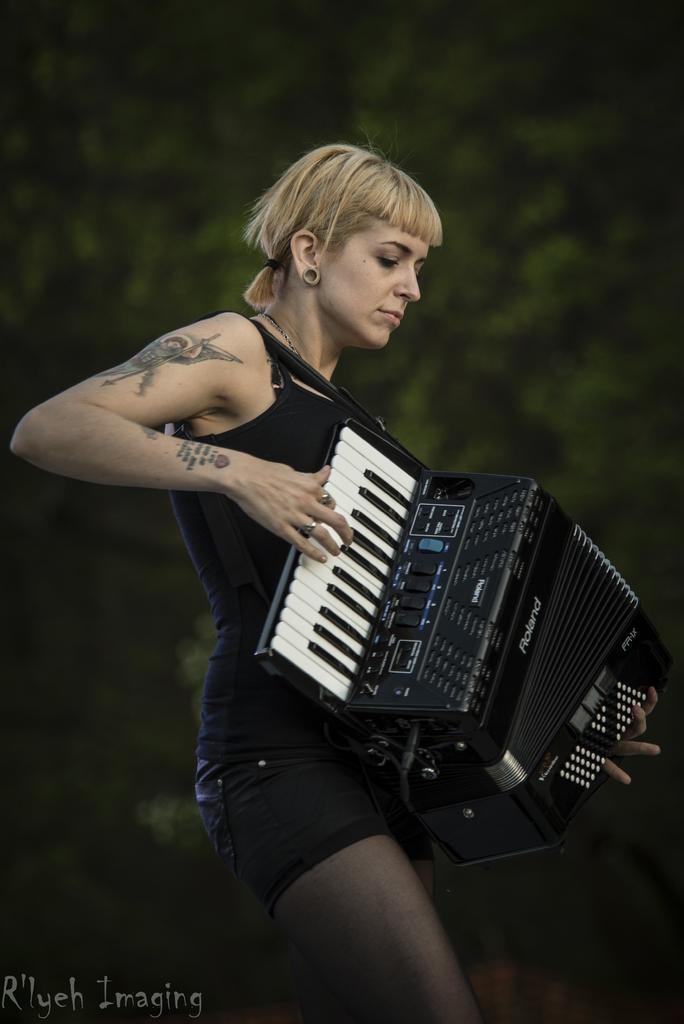In one or two sentences, can you explain what this image depicts? In the image there is a woman in black dress playing a piano harmonium, in the back there is a tree. 